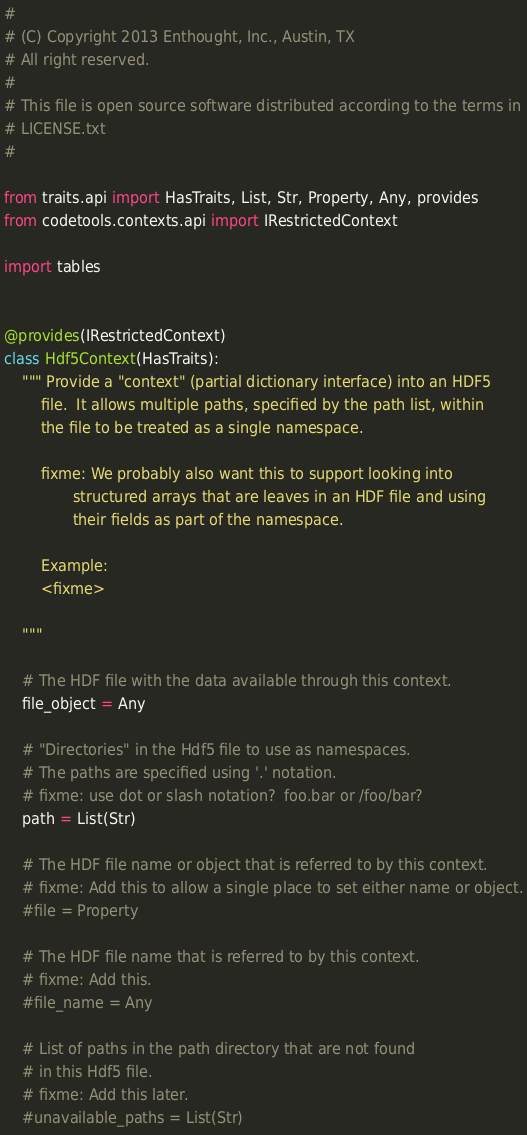Convert code to text. <code><loc_0><loc_0><loc_500><loc_500><_Python_>#
# (C) Copyright 2013 Enthought, Inc., Austin, TX
# All right reserved.
#
# This file is open source software distributed according to the terms in
# LICENSE.txt
#

from traits.api import HasTraits, List, Str, Property, Any, provides
from codetools.contexts.api import IRestrictedContext

import tables


@provides(IRestrictedContext)
class Hdf5Context(HasTraits):
    """ Provide a "context" (partial dictionary interface) into an HDF5
        file.  It allows multiple paths, specified by the path list, within
        the file to be treated as a single namespace.

        fixme: We probably also want this to support looking into
               structured arrays that are leaves in an HDF file and using
               their fields as part of the namespace.

        Example:
        <fixme>

    """

    # The HDF file with the data available through this context.
    file_object = Any

    # "Directories" in the Hdf5 file to use as namespaces.
    # The paths are specified using '.' notation.
    # fixme: use dot or slash notation?  foo.bar or /foo/bar?
    path = List(Str)

    # The HDF file name or object that is referred to by this context.
    # fixme: Add this to allow a single place to set either name or object.
    #file = Property

    # The HDF file name that is referred to by this context.
    # fixme: Add this.
    #file_name = Any

    # List of paths in the path directory that are not found
    # in this Hdf5 file.
    # fixme: Add this later.
    #unavailable_paths = List(Str)
</code> 